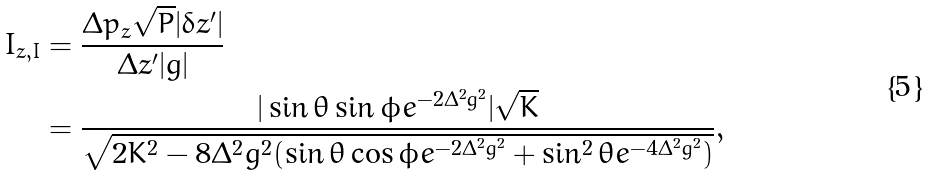<formula> <loc_0><loc_0><loc_500><loc_500>I _ { z , I } & = \frac { \Delta p _ { z } \sqrt { P } | \delta z ^ { \prime } | } { \Delta z ^ { \prime } | g | } \\ & = \frac { | \sin { \theta } \sin { \phi } e ^ { - 2 \Delta ^ { 2 } g ^ { 2 } } | \sqrt { K } } { \sqrt { 2 K ^ { 2 } - 8 \Delta ^ { 2 } g ^ { 2 } ( \sin { \theta } \cos { \phi } e ^ { - 2 \Delta ^ { 2 } g ^ { 2 } } + \sin ^ { 2 } { \theta } e ^ { - 4 \Delta ^ { 2 } g ^ { 2 } } ) } } ,</formula> 